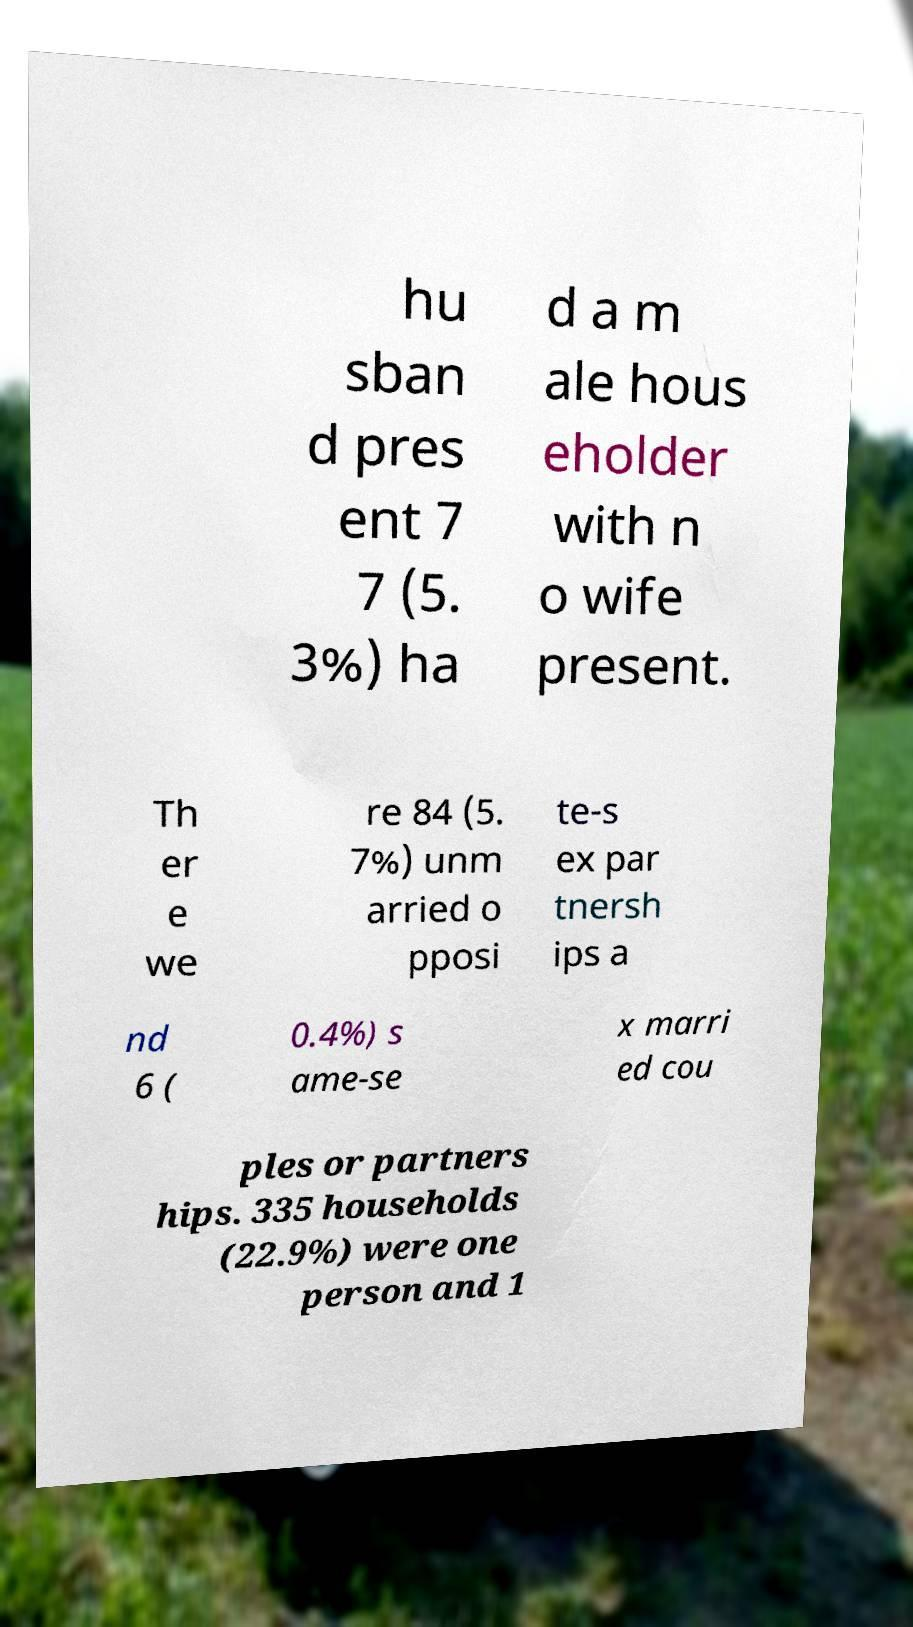Please read and relay the text visible in this image. What does it say? hu sban d pres ent 7 7 (5. 3%) ha d a m ale hous eholder with n o wife present. Th er e we re 84 (5. 7%) unm arried o pposi te-s ex par tnersh ips a nd 6 ( 0.4%) s ame-se x marri ed cou ples or partners hips. 335 households (22.9%) were one person and 1 